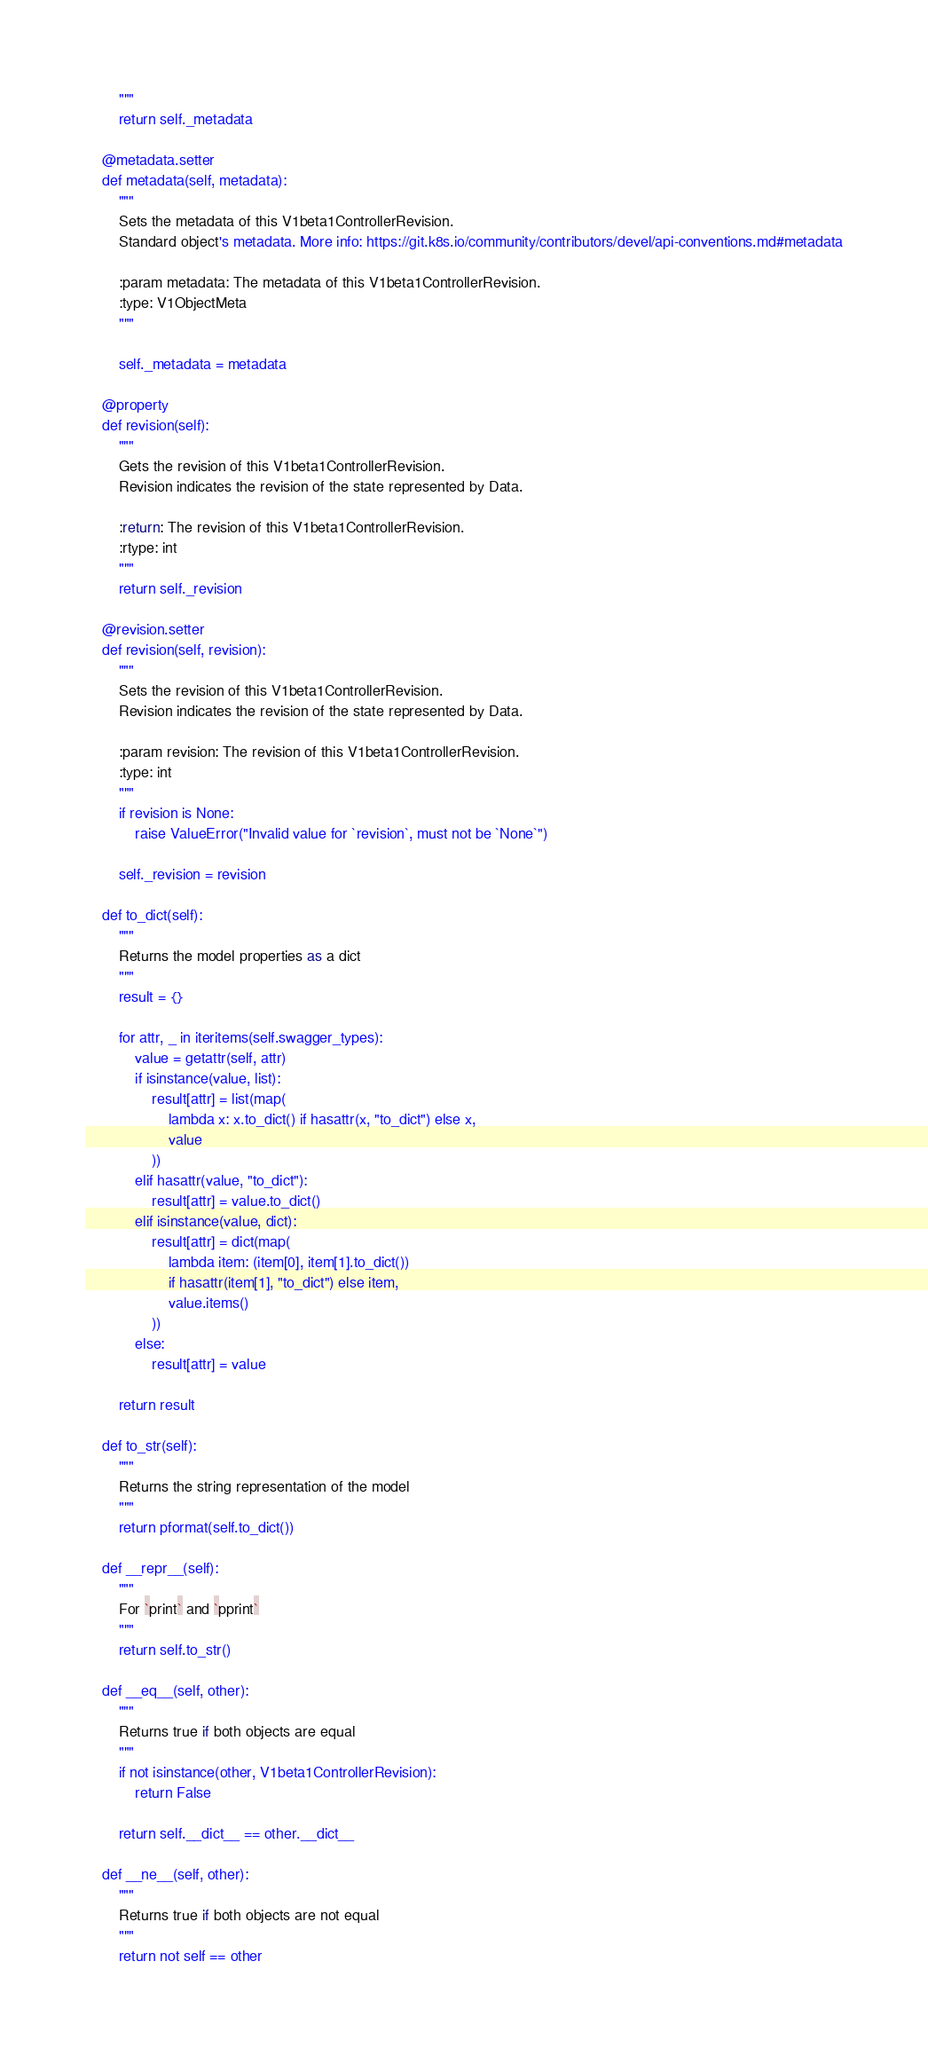<code> <loc_0><loc_0><loc_500><loc_500><_Python_>        """
        return self._metadata

    @metadata.setter
    def metadata(self, metadata):
        """
        Sets the metadata of this V1beta1ControllerRevision.
        Standard object's metadata. More info: https://git.k8s.io/community/contributors/devel/api-conventions.md#metadata

        :param metadata: The metadata of this V1beta1ControllerRevision.
        :type: V1ObjectMeta
        """

        self._metadata = metadata

    @property
    def revision(self):
        """
        Gets the revision of this V1beta1ControllerRevision.
        Revision indicates the revision of the state represented by Data.

        :return: The revision of this V1beta1ControllerRevision.
        :rtype: int
        """
        return self._revision

    @revision.setter
    def revision(self, revision):
        """
        Sets the revision of this V1beta1ControllerRevision.
        Revision indicates the revision of the state represented by Data.

        :param revision: The revision of this V1beta1ControllerRevision.
        :type: int
        """
        if revision is None:
            raise ValueError("Invalid value for `revision`, must not be `None`")

        self._revision = revision

    def to_dict(self):
        """
        Returns the model properties as a dict
        """
        result = {}

        for attr, _ in iteritems(self.swagger_types):
            value = getattr(self, attr)
            if isinstance(value, list):
                result[attr] = list(map(
                    lambda x: x.to_dict() if hasattr(x, "to_dict") else x,
                    value
                ))
            elif hasattr(value, "to_dict"):
                result[attr] = value.to_dict()
            elif isinstance(value, dict):
                result[attr] = dict(map(
                    lambda item: (item[0], item[1].to_dict())
                    if hasattr(item[1], "to_dict") else item,
                    value.items()
                ))
            else:
                result[attr] = value

        return result

    def to_str(self):
        """
        Returns the string representation of the model
        """
        return pformat(self.to_dict())

    def __repr__(self):
        """
        For `print` and `pprint`
        """
        return self.to_str()

    def __eq__(self, other):
        """
        Returns true if both objects are equal
        """
        if not isinstance(other, V1beta1ControllerRevision):
            return False

        return self.__dict__ == other.__dict__

    def __ne__(self, other):
        """
        Returns true if both objects are not equal
        """
        return not self == other
</code> 